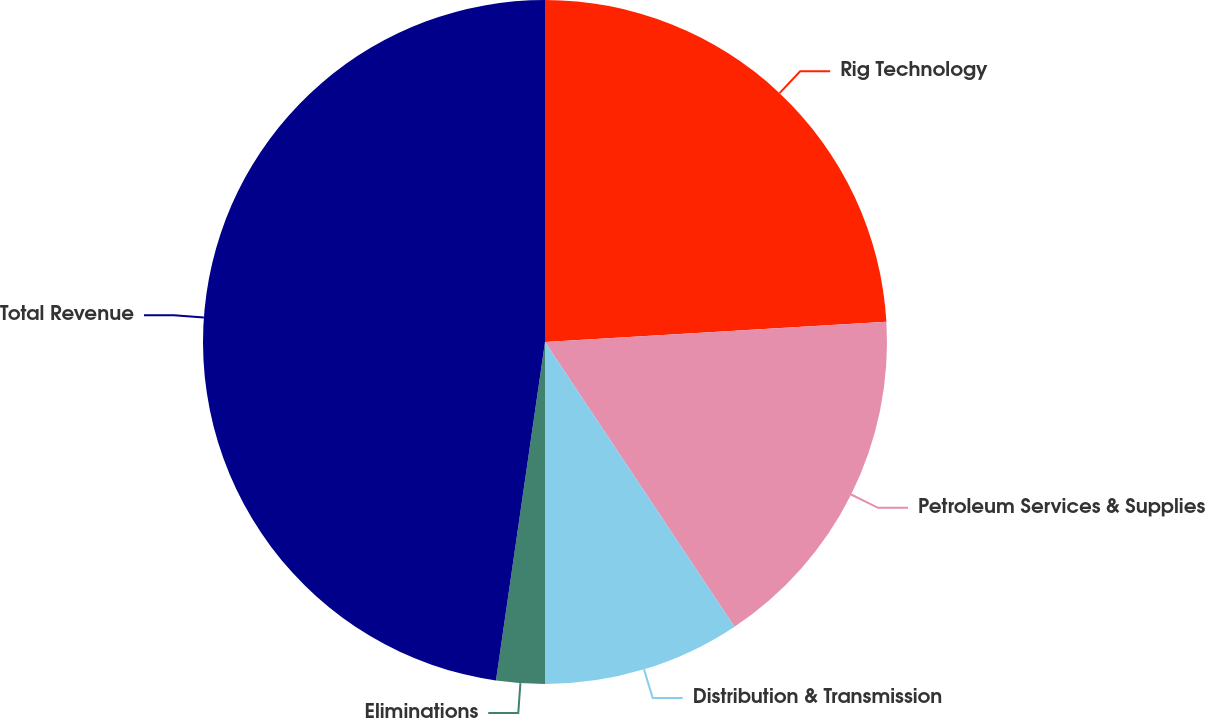<chart> <loc_0><loc_0><loc_500><loc_500><pie_chart><fcel>Rig Technology<fcel>Petroleum Services & Supplies<fcel>Distribution & Transmission<fcel>Eliminations<fcel>Total Revenue<nl><fcel>24.06%<fcel>16.59%<fcel>9.35%<fcel>2.29%<fcel>47.71%<nl></chart> 